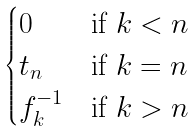Convert formula to latex. <formula><loc_0><loc_0><loc_500><loc_500>\begin{cases} 0 & \text {if $k<n$} \\ t _ { n } & \text {if $k=n$} \\ f _ { k } ^ { - 1 } & \text {if $k>n$} \end{cases}</formula> 